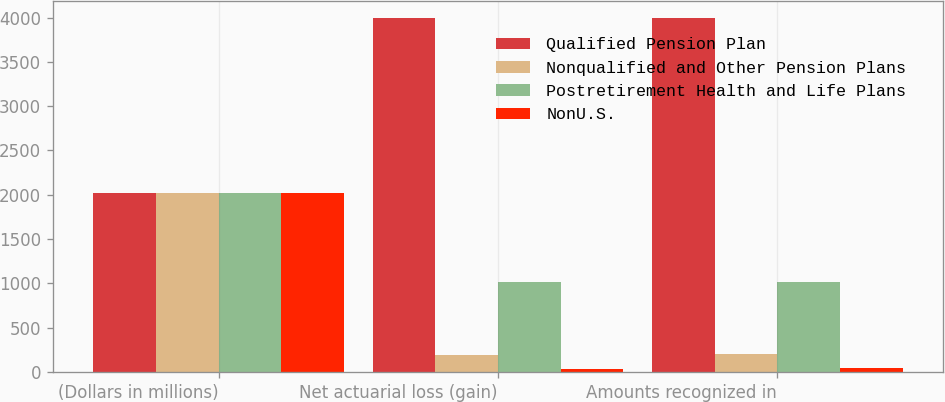Convert chart to OTSL. <chart><loc_0><loc_0><loc_500><loc_500><stacked_bar_chart><ecel><fcel>(Dollars in millions)<fcel>Net actuarial loss (gain)<fcel>Amounts recognized in<nl><fcel>Qualified Pension Plan<fcel>2017<fcel>3992<fcel>3992<nl><fcel>Nonqualified and Other Pension Plans<fcel>2017<fcel>196<fcel>200<nl><fcel>Postretirement Health and Life Plans<fcel>2017<fcel>1014<fcel>1014<nl><fcel>NonU.S.<fcel>2017<fcel>30<fcel>41<nl></chart> 